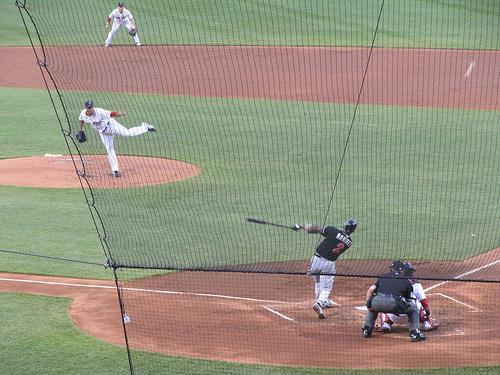How many umpires can be seen?
Give a very brief answer. 1. 